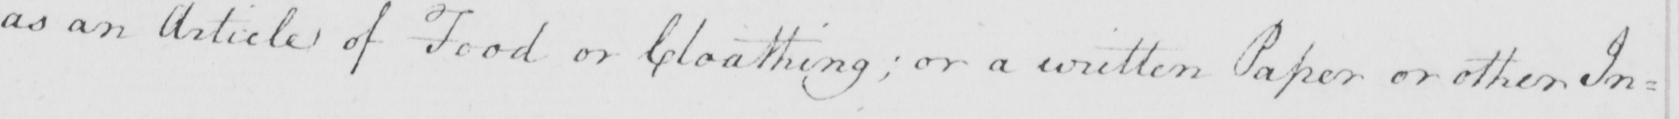Transcribe the text shown in this historical manuscript line. as an article of Food or Cloathing ; or a written Paper or other In : 